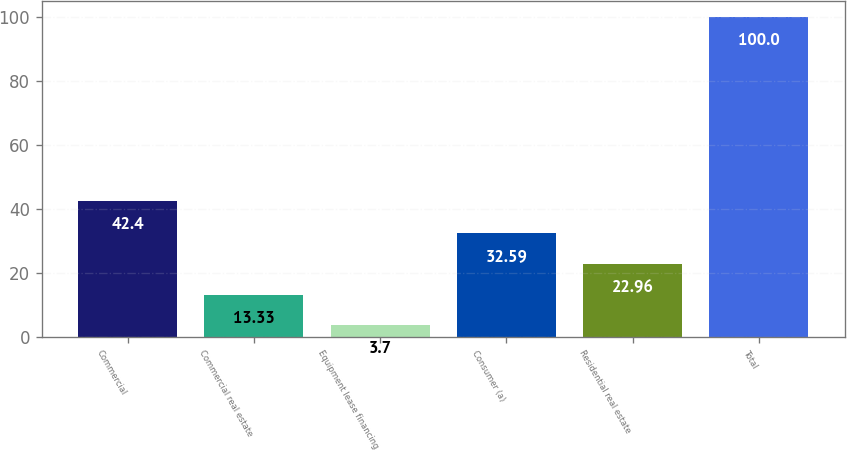<chart> <loc_0><loc_0><loc_500><loc_500><bar_chart><fcel>Commercial<fcel>Commercial real estate<fcel>Equipment lease financing<fcel>Consumer (a)<fcel>Residential real estate<fcel>Total<nl><fcel>42.4<fcel>13.33<fcel>3.7<fcel>32.59<fcel>22.96<fcel>100<nl></chart> 